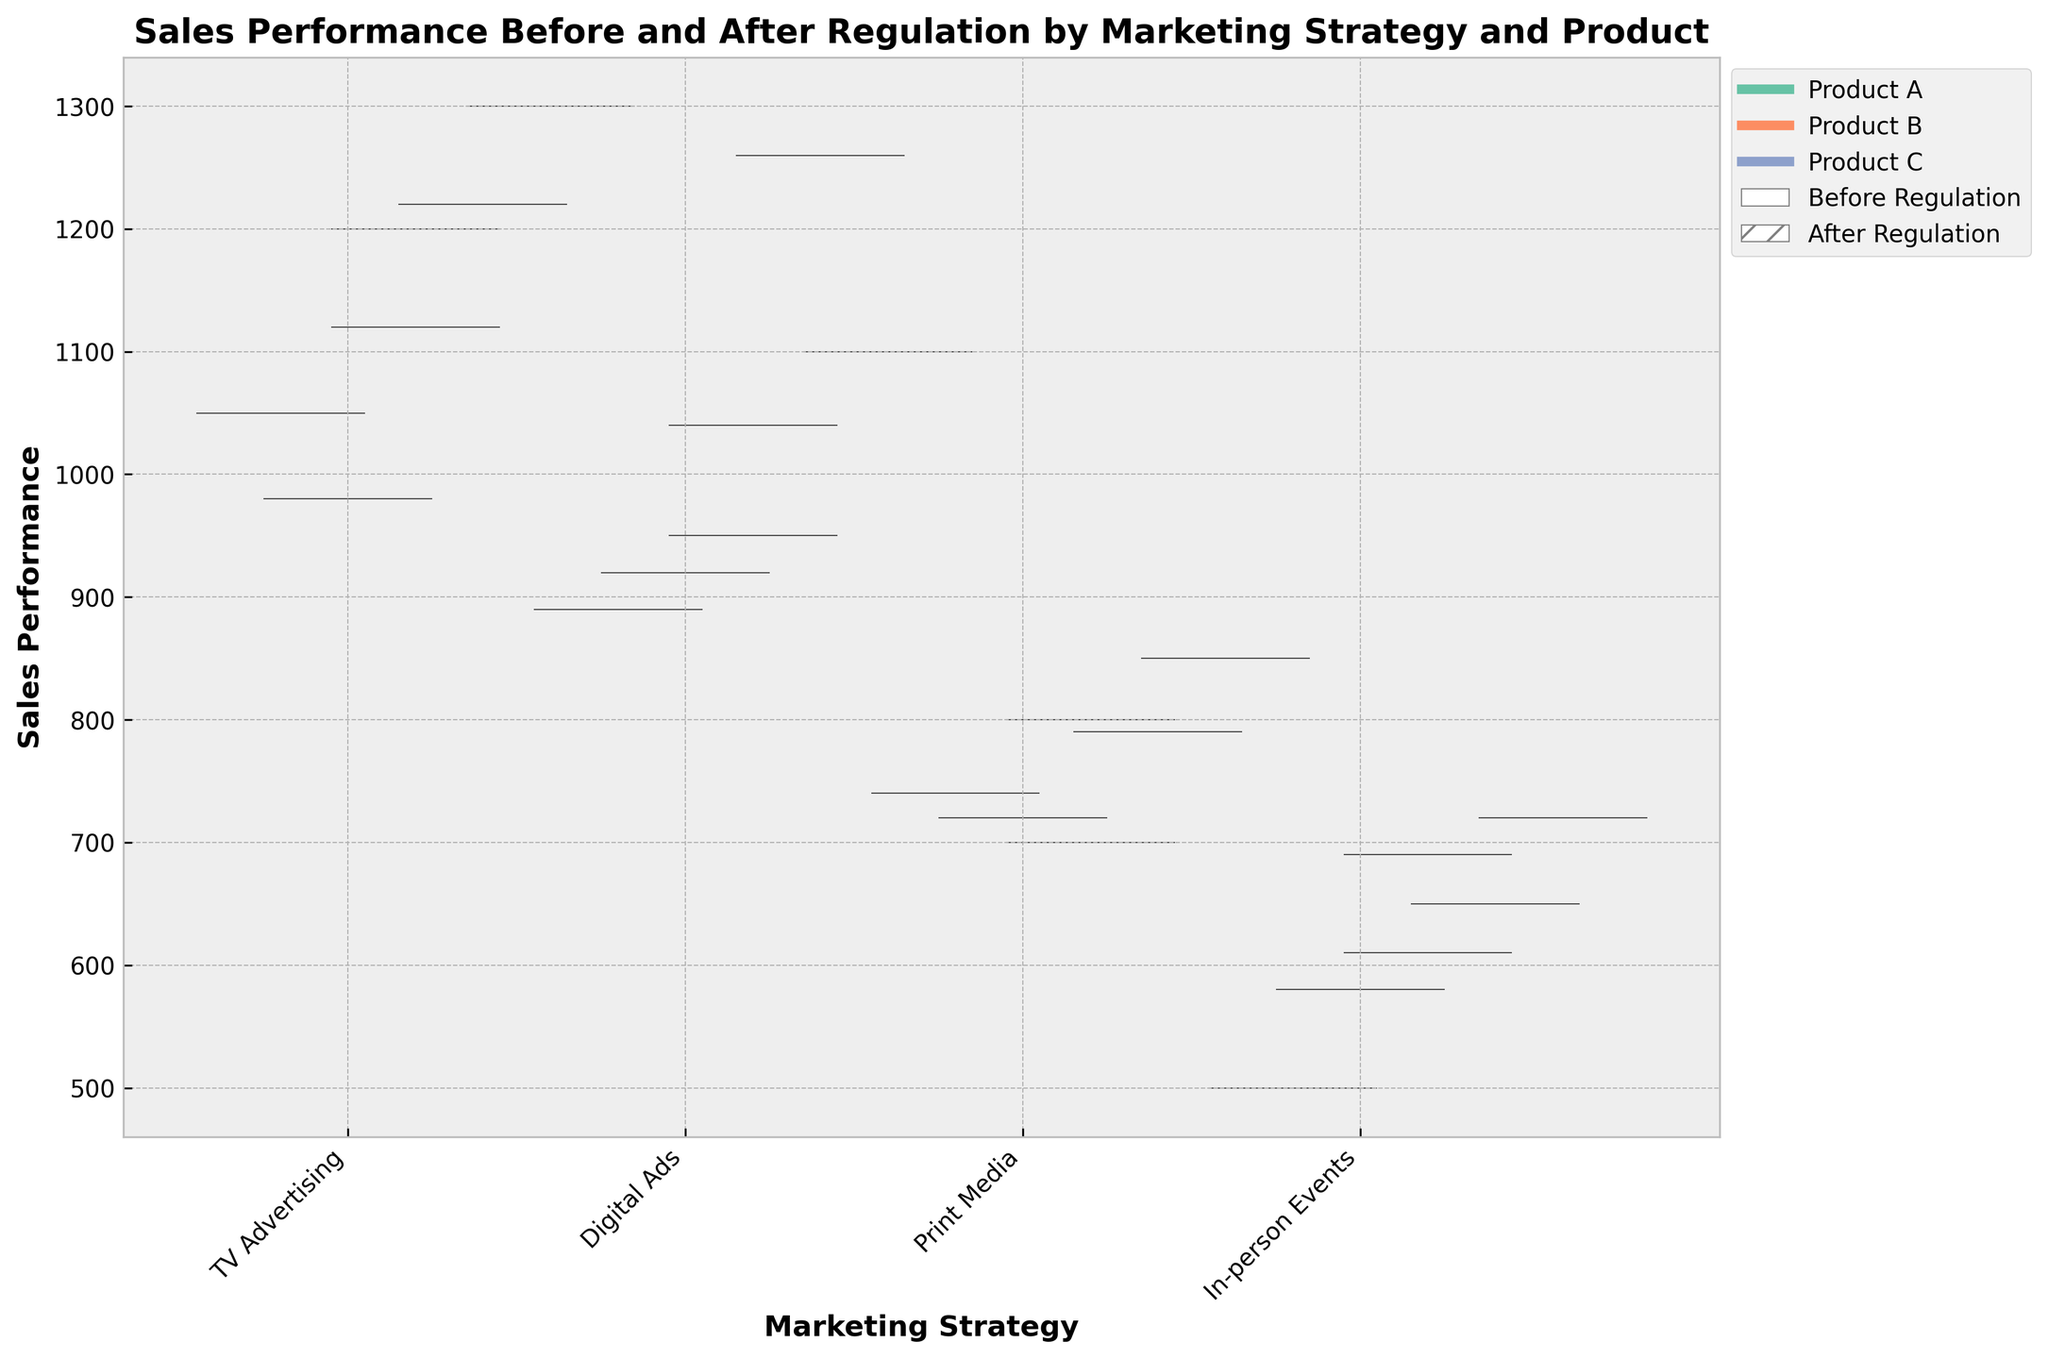What's the title of the figure? The title is usually displayed at the top center of the figure. In this case, the title text in bold sets a clear purpose of the visual.
Answer: Sales Performance Before and After Regulation by Marketing Strategy and Product What are the labels of the x-axis and y-axis? The labels of the axes are typically displayed directly beside each axis. The x-axis indicates the categories being compared, and the y-axis represents the measured values.
Answer: x-axis: Marketing Strategy, y-axis: Sales Performance Which marketing strategy has higher sales for Product A after the regulation? Look for the sections of the plot marked with hatch lines representing "After Regulation." Compare the heights of these sections for Product A across all strategies.
Answer: TV Advertising How does the median sales performance of Product B change after the regulation for Digital Ads? The median value can be inferred from the thickest part of each violin plot segment. For Product B and Digital Ads, compare the thicker sections before and after regulation.
Answer: It increases Which product shows the least increase in sales performance after the regulation under Print Media? Compare the difference in height between the "Before Regulation" (plain) and "After Regulation" (hatch) segments for each product under Print Media.
Answer: Product B What pattern can you observe about the sales performance before and after the regulation across all products for In-person Events? Assess the overall trend by scanning each product's violin plot segments for In-person Events and checking if they are higher or lower after regulation.
Answer: Sales performance generally increased Which marketing strategy had roughly similar sales performance for Product A before and after the regulation? Examine the amplitude of the sections marked as "Before Regulation" (plain) and "After Regulation" (hatch) for Product A across all strategies. Identify the strategy with minimal change.
Answer: Digital Ads Among the depicted marketing strategies, which one shows the most pronounced difference between before and after regulation for Product C? To determine the largest difference, look for the farthest spread between the plain and hatched sections for Product C among all strategies.
Answer: TV Advertising Are the differences between the before and after regulation sales greater for Digital Ads or Print Media for Product C? Compare the spread between the plain and hatched sections for Product C within Digital Ads and Print Media. The larger difference indicates greater sales change.
Answer: Digital Ads 